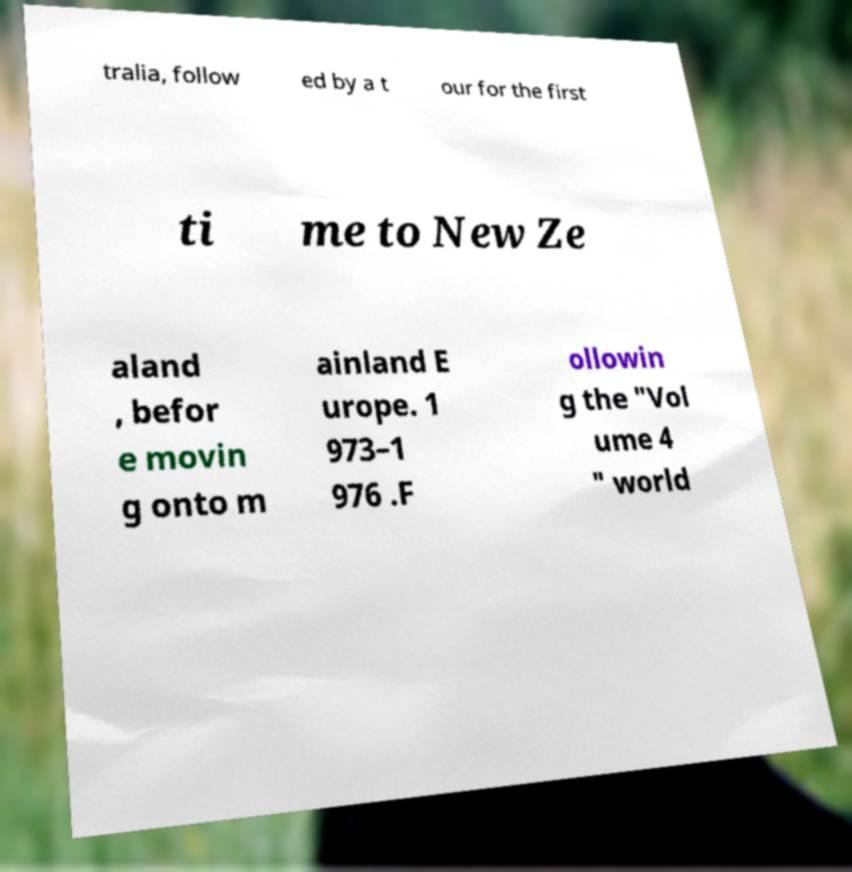Please read and relay the text visible in this image. What does it say? tralia, follow ed by a t our for the first ti me to New Ze aland , befor e movin g onto m ainland E urope. 1 973–1 976 .F ollowin g the "Vol ume 4 " world 